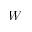Convert formula to latex. <formula><loc_0><loc_0><loc_500><loc_500>W</formula> 